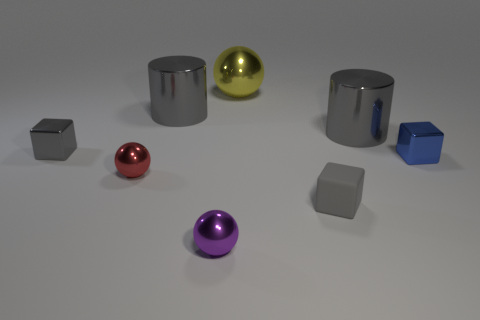There is a purple object that is the same shape as the yellow thing; what size is it?
Your answer should be very brief. Small. Does the small matte cube have the same color as the large ball?
Offer a very short reply. No. What color is the object that is to the right of the small purple sphere and to the left of the rubber block?
Provide a succinct answer. Yellow. There is a gray shiny cylinder that is right of the yellow metal thing; is it the same size as the tiny purple metal thing?
Provide a succinct answer. No. Are there any other things that have the same shape as the blue object?
Keep it short and to the point. Yes. Do the small blue block and the gray cube that is behind the tiny rubber cube have the same material?
Keep it short and to the point. Yes. How many gray objects are either metal balls or matte blocks?
Your response must be concise. 1. Are there any large green balls?
Provide a succinct answer. No. Are there any objects that are on the right side of the tiny gray block that is on the right side of the metal cube behind the small blue shiny cube?
Provide a succinct answer. Yes. Is there anything else that is the same size as the red metallic sphere?
Give a very brief answer. Yes. 